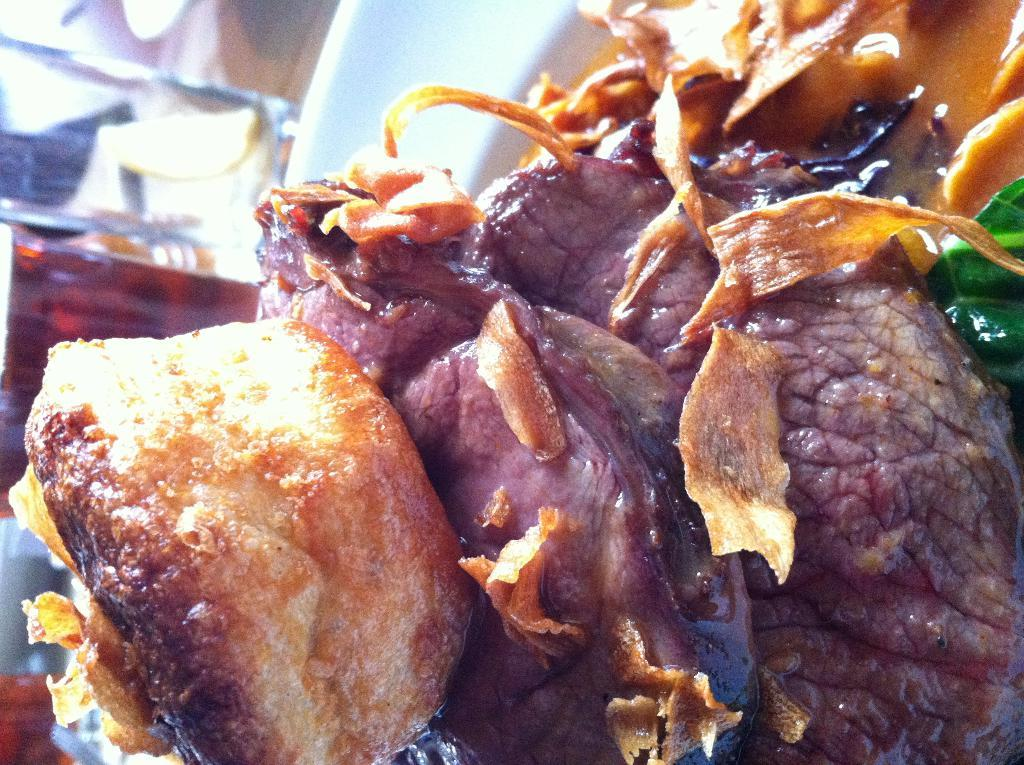What is on the plate that is visible in the image? The plate contains meat. Are there any other food items on the plate besides the meat? Yes, there is additional food on the plate. What type of horn can be seen on the plate in the image? There is no horn present on the plate in the image. What story is being told by the food on the plate? The food on the plate is not telling a story; it is simply a meal. 